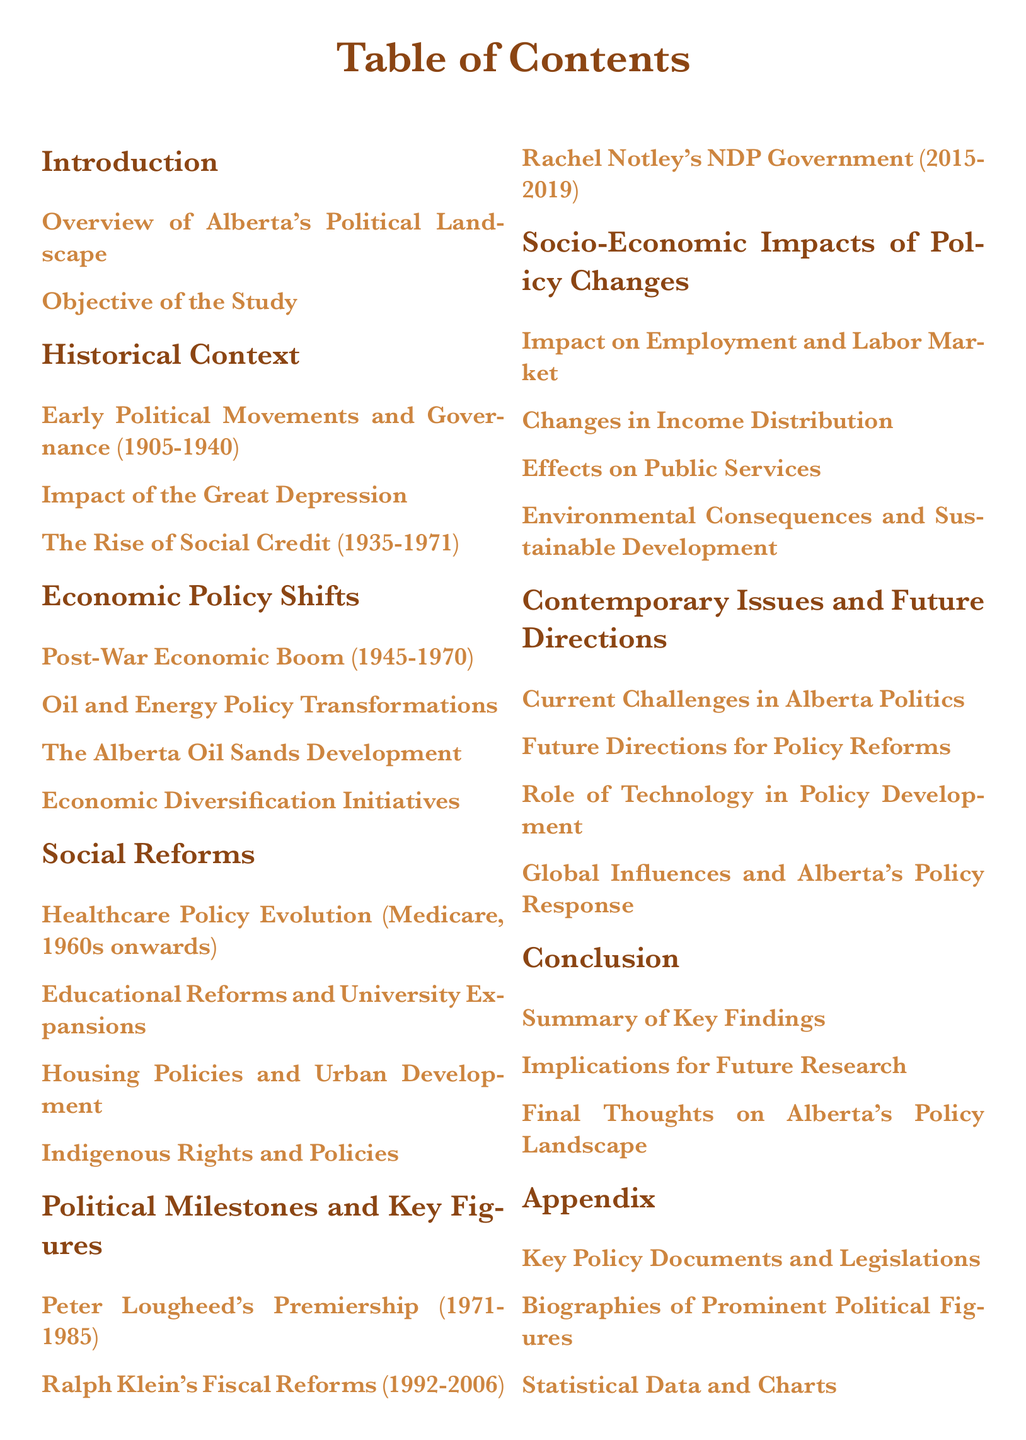What is the subject of the study? The objective of the study is outlined in the Introduction section.
Answer: Impact on Alberta's Socio-Economic Landscape Which political movement was prominent from 1935 to 1971? This information can be found in the Historical Context section.
Answer: Social Credit What period does Peter Lougheed's premiership cover? The specific time span of Peter Lougheed's premiership is detailed in the Political Milestones section.
Answer: 1971-1985 What was a key feature of the healthcare evolution mentioned? This is discussed under Social Reforms regarding healthcare policy.
Answer: Medicare Which section covers employment impacts? The impact on employment and labor market is discussed in Socio-Economic Impacts of Policy Changes.
Answer: Socio-Economic Impacts of Policy Changes What are the two challenges mentioned in the Contemporary Issues section? The challenges are listed in the Contemporary Issues and Future Directions section.
Answer: Current Challenges in Alberta Politics How many sub-sections are found under the Social Reforms section? The number of sub-sections in Social Reforms can be counted from the Table of Contents.
Answer: Four What is mentioned about Alberta's Oil Sands Development? This topic is covered in the Economic Policy Shifts section.
Answer: Alberta Oil Sands Development Which political figure's fiscal reforms are discussed? This information is located in the Political Milestones and Key Figures section.
Answer: Ralph Klein 